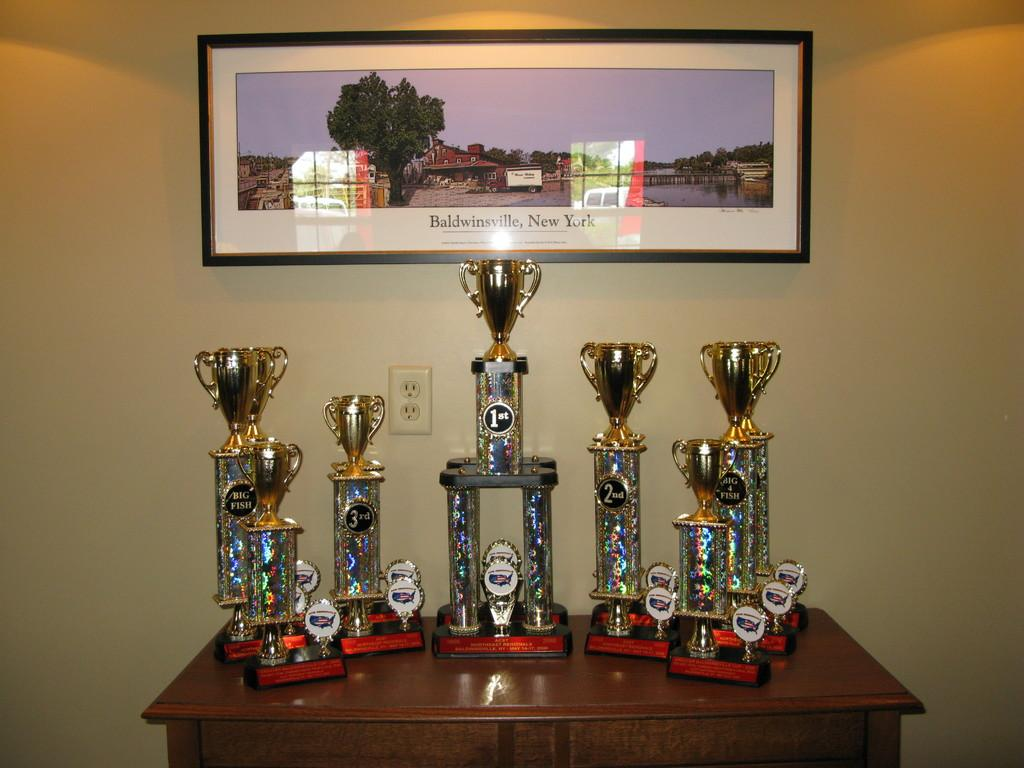Provide a one-sentence caption for the provided image. Seven large golden cup trophies sitting a oak cabinet . 